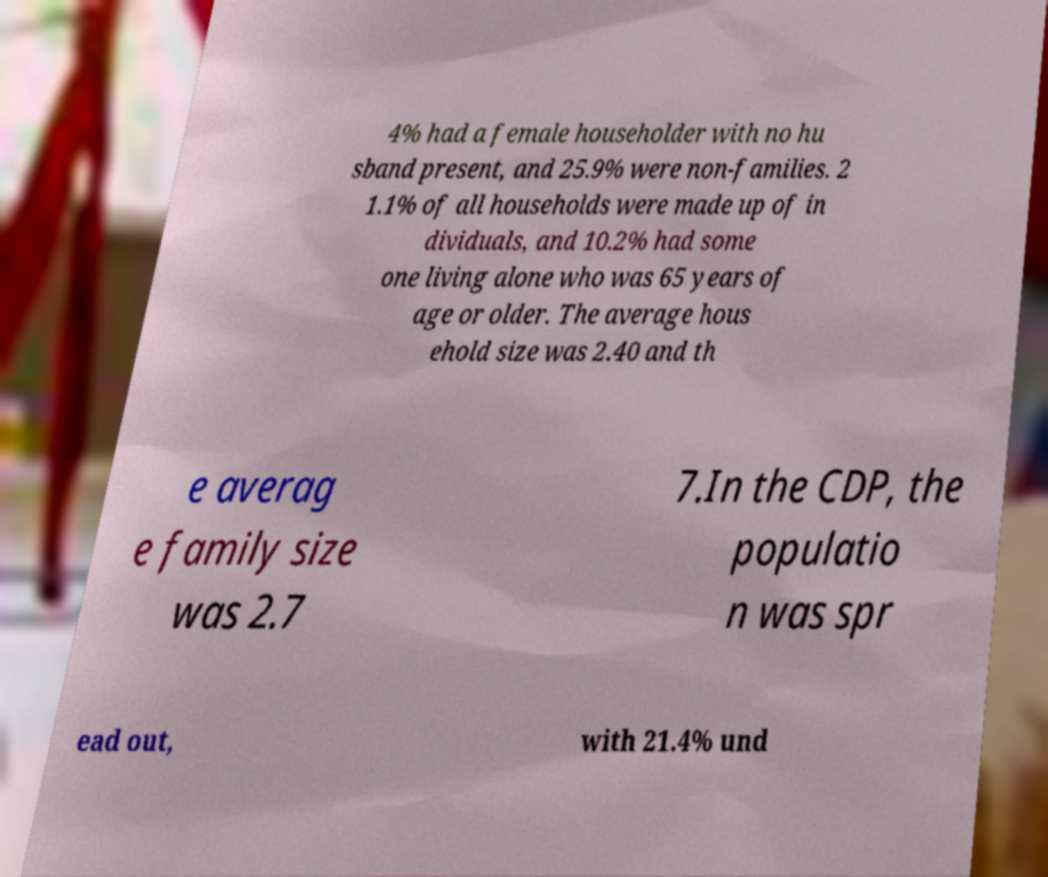Can you read and provide the text displayed in the image?This photo seems to have some interesting text. Can you extract and type it out for me? 4% had a female householder with no hu sband present, and 25.9% were non-families. 2 1.1% of all households were made up of in dividuals, and 10.2% had some one living alone who was 65 years of age or older. The average hous ehold size was 2.40 and th e averag e family size was 2.7 7.In the CDP, the populatio n was spr ead out, with 21.4% und 